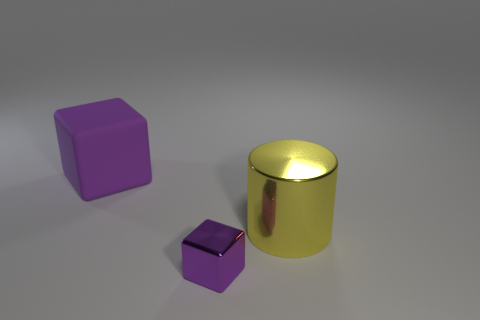How does the lighting in the image affect the appearance of the objects? The soft and diffused lighting in the image highlights the objects' textures and colors. The metal cube and cylinder reflect light strongly due to their glossiness, which creates a sharp contrast with the matte finish of the rubber cube. 